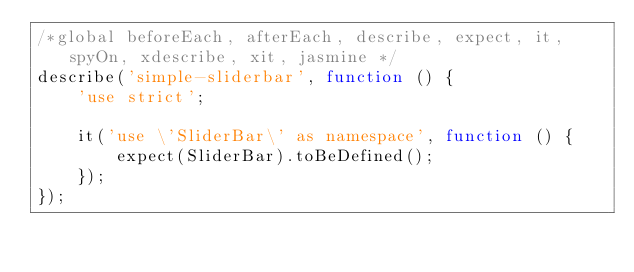<code> <loc_0><loc_0><loc_500><loc_500><_JavaScript_>/*global beforeEach, afterEach, describe, expect, it, spyOn, xdescribe, xit, jasmine */
describe('simple-sliderbar', function () {
    'use strict';

    it('use \'SliderBar\' as namespace', function () {
        expect(SliderBar).toBeDefined();
    });
});</code> 